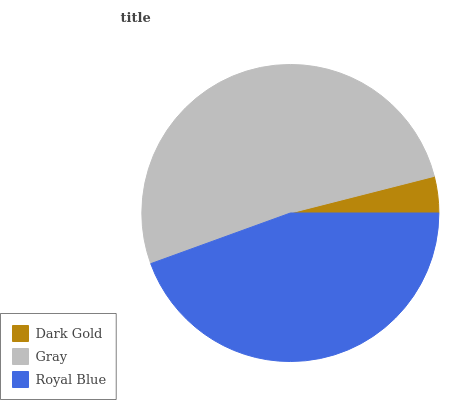Is Dark Gold the minimum?
Answer yes or no. Yes. Is Gray the maximum?
Answer yes or no. Yes. Is Royal Blue the minimum?
Answer yes or no. No. Is Royal Blue the maximum?
Answer yes or no. No. Is Gray greater than Royal Blue?
Answer yes or no. Yes. Is Royal Blue less than Gray?
Answer yes or no. Yes. Is Royal Blue greater than Gray?
Answer yes or no. No. Is Gray less than Royal Blue?
Answer yes or no. No. Is Royal Blue the high median?
Answer yes or no. Yes. Is Royal Blue the low median?
Answer yes or no. Yes. Is Gray the high median?
Answer yes or no. No. Is Gray the low median?
Answer yes or no. No. 